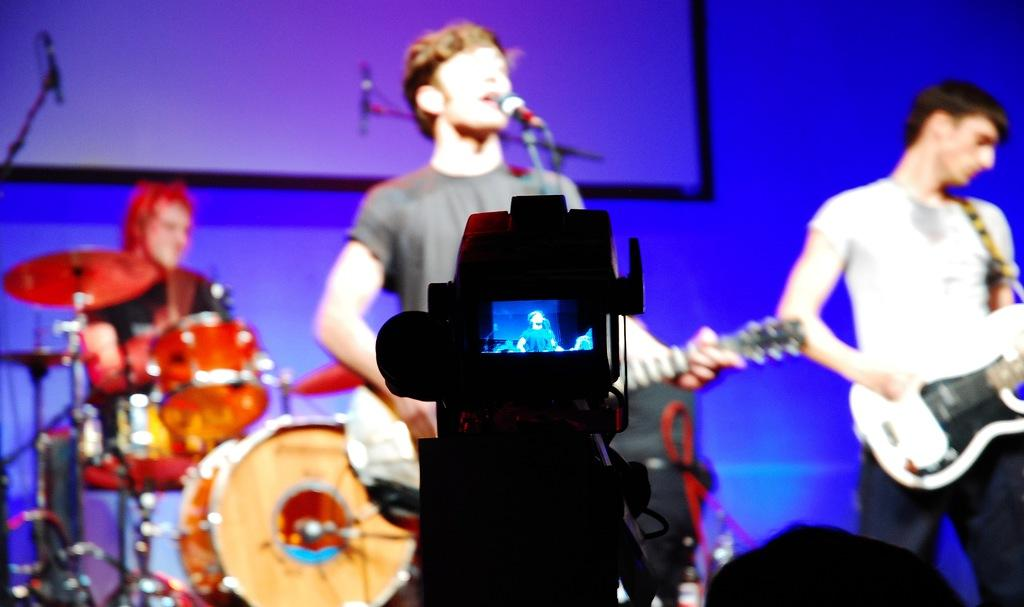How many people are in the image? There are people in the image, but the exact number is not specified. What are the people doing in the image? The people are standing and playing musical instruments. How is the scene being recorded? A video is capturing the scene. What type of houses can be seen in the background of the image? There is no mention of houses in the image, so we cannot answer this question. Is the person's sister playing an instrument in the image? The facts do not mention any specific individuals or relationships, so we cannot answer this question. 